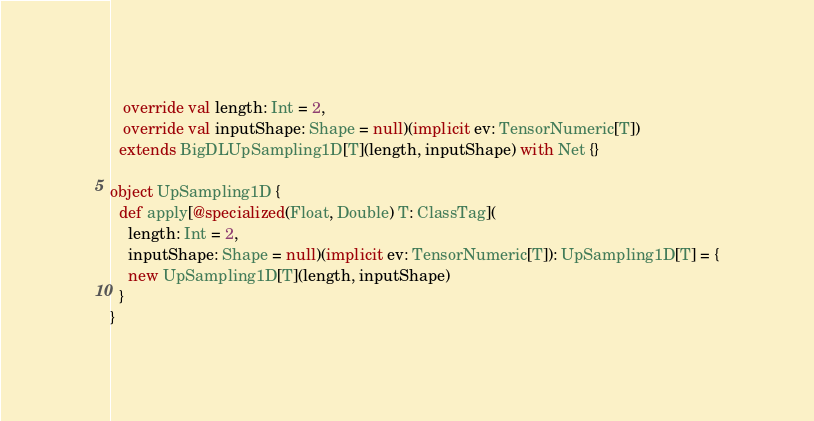<code> <loc_0><loc_0><loc_500><loc_500><_Scala_>   override val length: Int = 2,
   override val inputShape: Shape = null)(implicit ev: TensorNumeric[T])
  extends BigDLUpSampling1D[T](length, inputShape) with Net {}

object UpSampling1D {
  def apply[@specialized(Float, Double) T: ClassTag](
    length: Int = 2,
    inputShape: Shape = null)(implicit ev: TensorNumeric[T]): UpSampling1D[T] = {
    new UpSampling1D[T](length, inputShape)
  }
}
</code> 